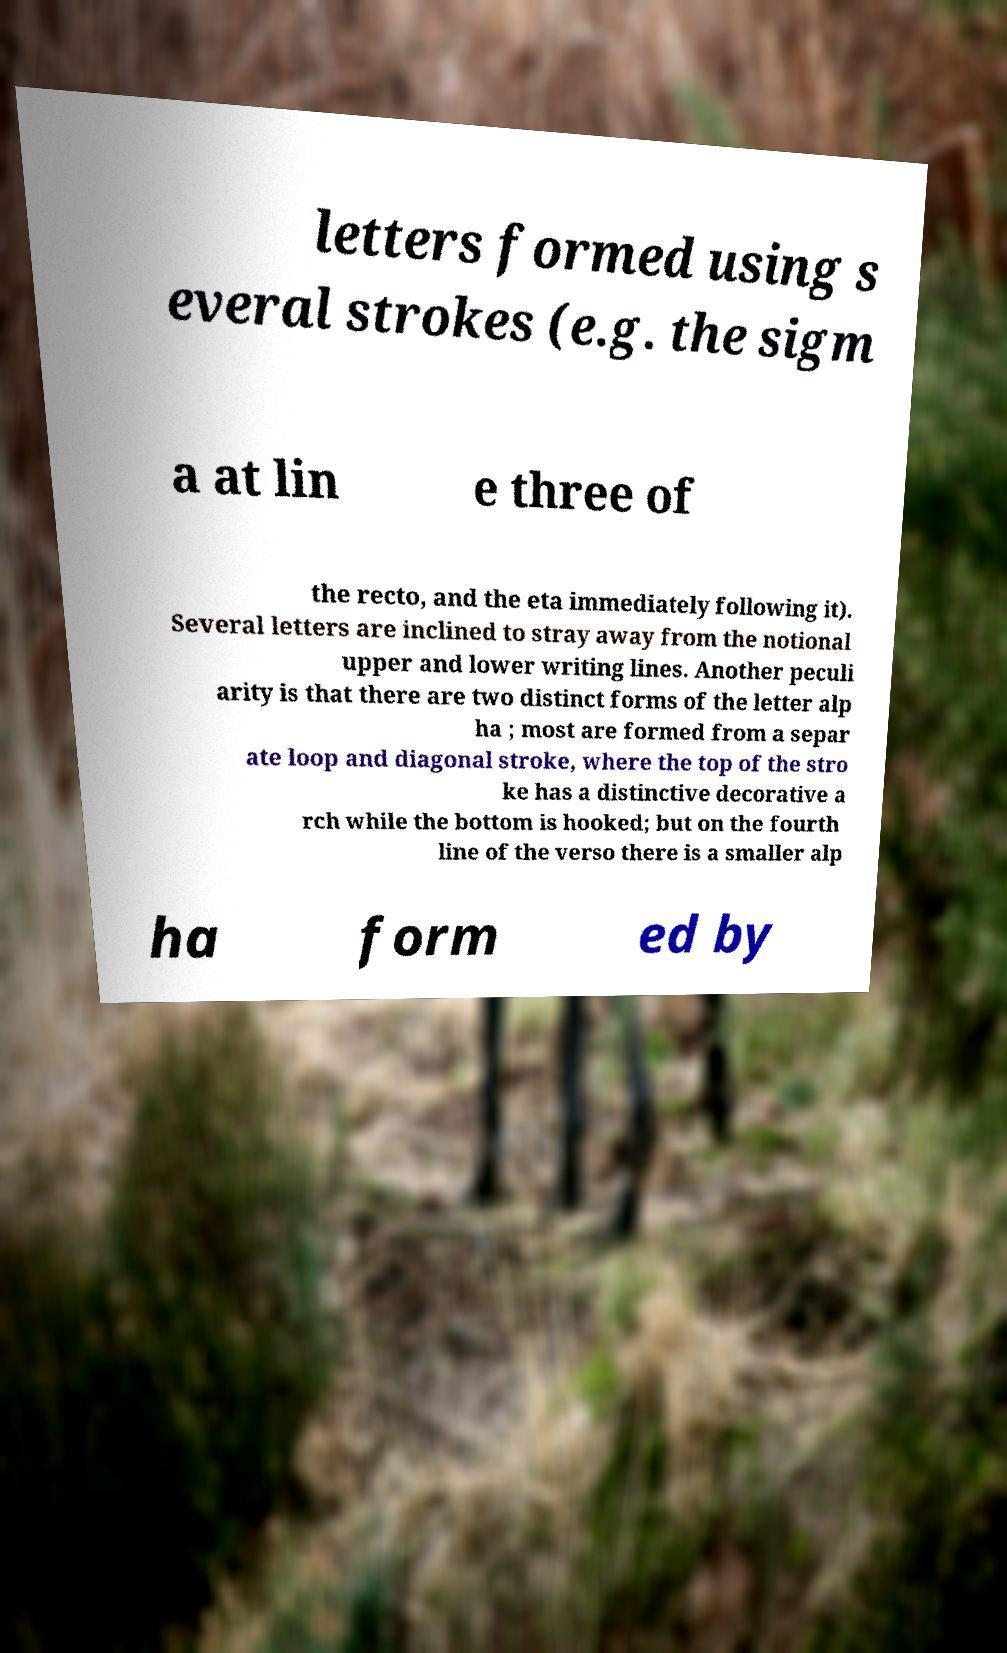For documentation purposes, I need the text within this image transcribed. Could you provide that? letters formed using s everal strokes (e.g. the sigm a at lin e three of the recto, and the eta immediately following it). Several letters are inclined to stray away from the notional upper and lower writing lines. Another peculi arity is that there are two distinct forms of the letter alp ha ; most are formed from a separ ate loop and diagonal stroke, where the top of the stro ke has a distinctive decorative a rch while the bottom is hooked; but on the fourth line of the verso there is a smaller alp ha form ed by 